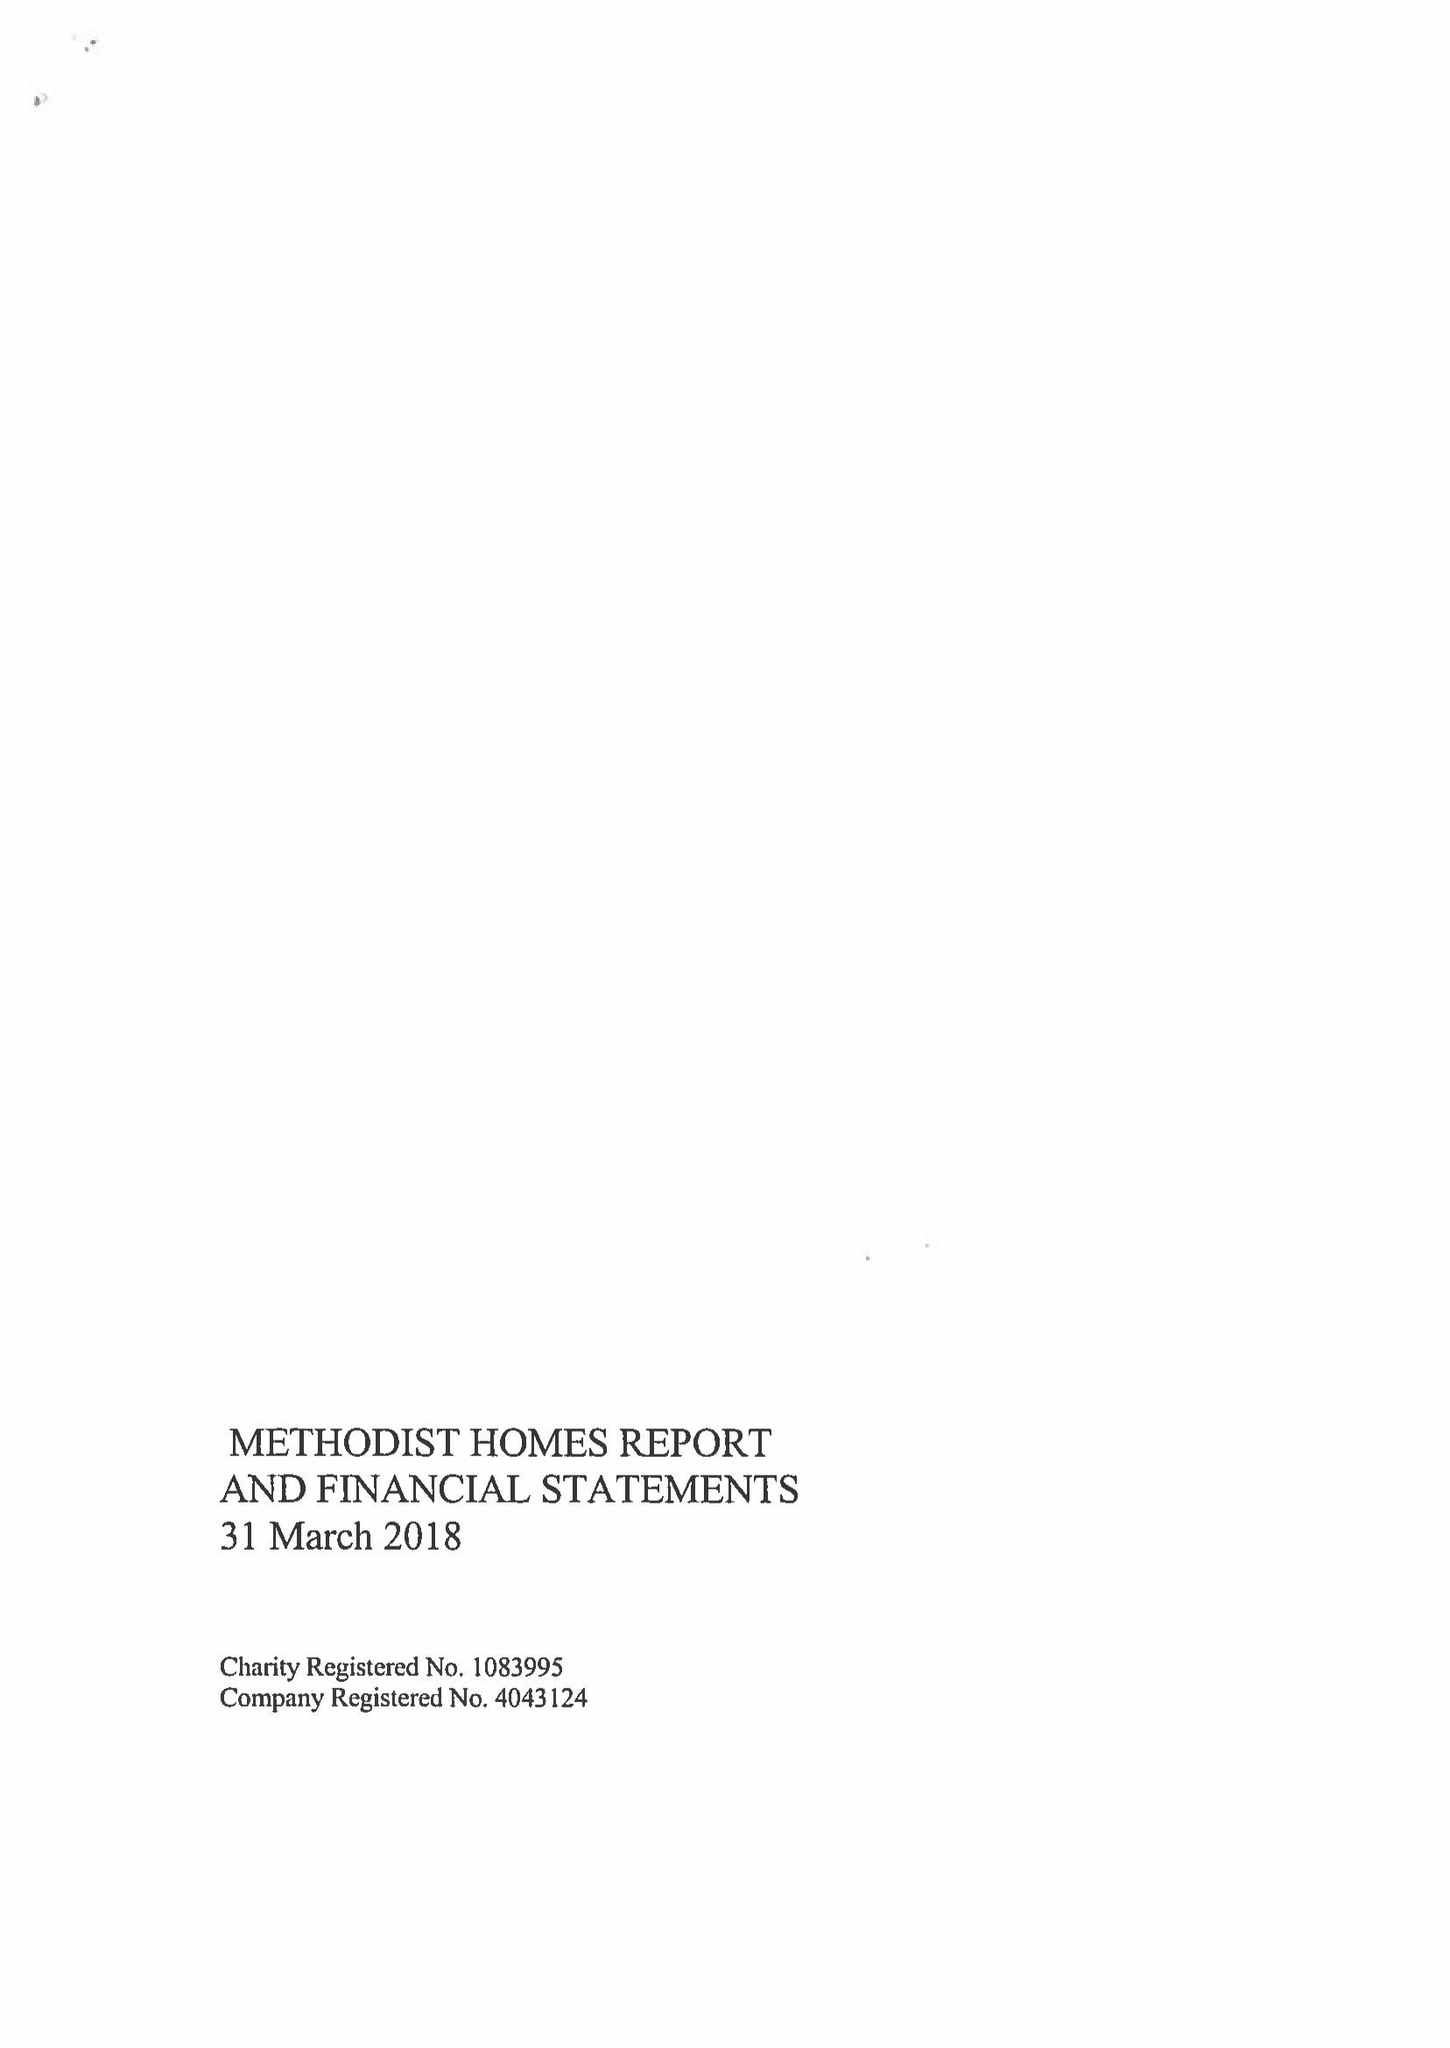What is the value for the address__post_town?
Answer the question using a single word or phrase. DERBY 